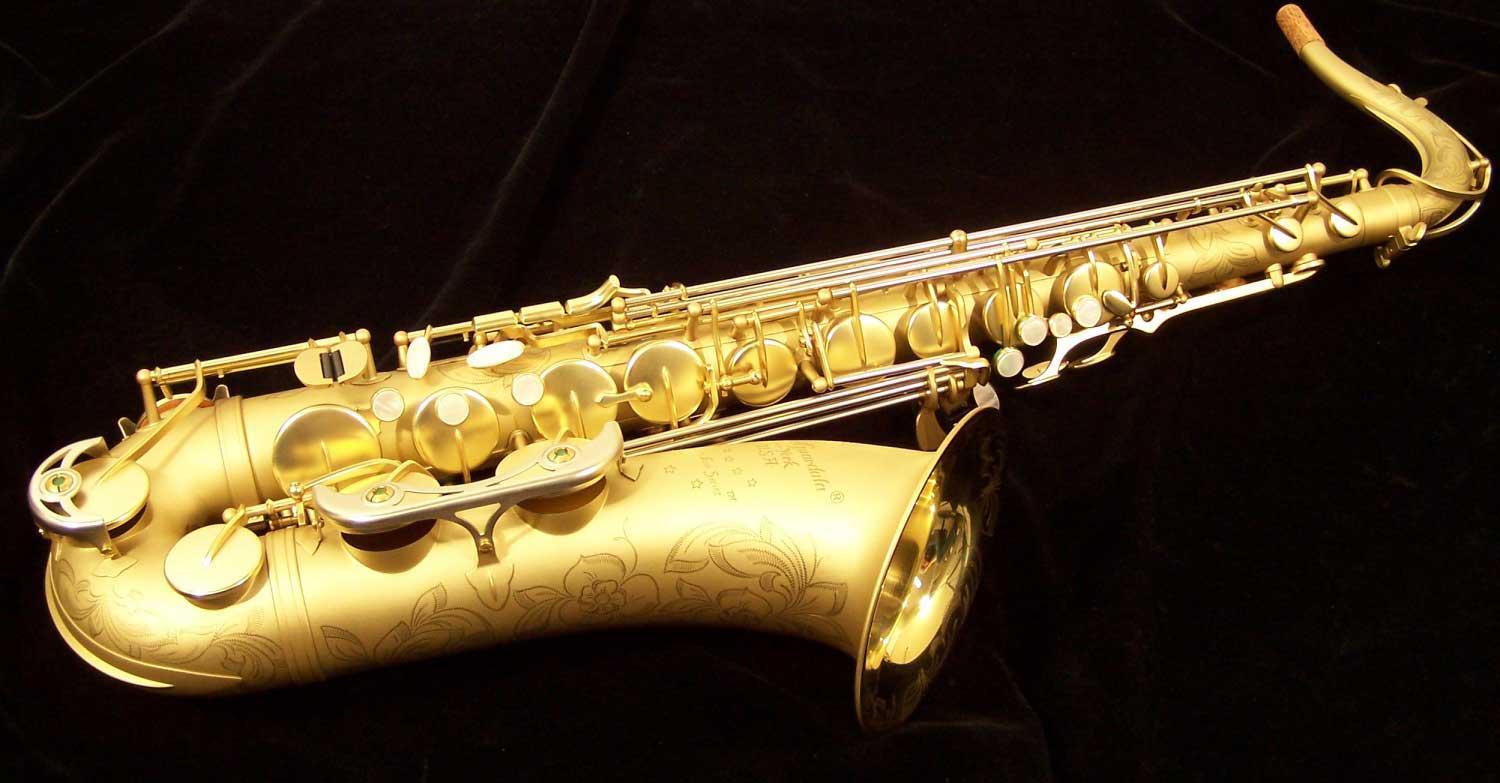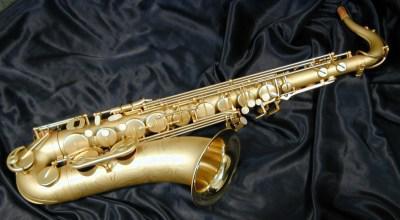The first image is the image on the left, the second image is the image on the right. Considering the images on both sides, is "An image shows a saxophone displayed with its open, black-lined case." valid? Answer yes or no. No. The first image is the image on the left, the second image is the image on the right. Analyze the images presented: Is the assertion "One saxophone has two extra mouth pieces beside it and one saxophone is shown with a black lined case." valid? Answer yes or no. No. 